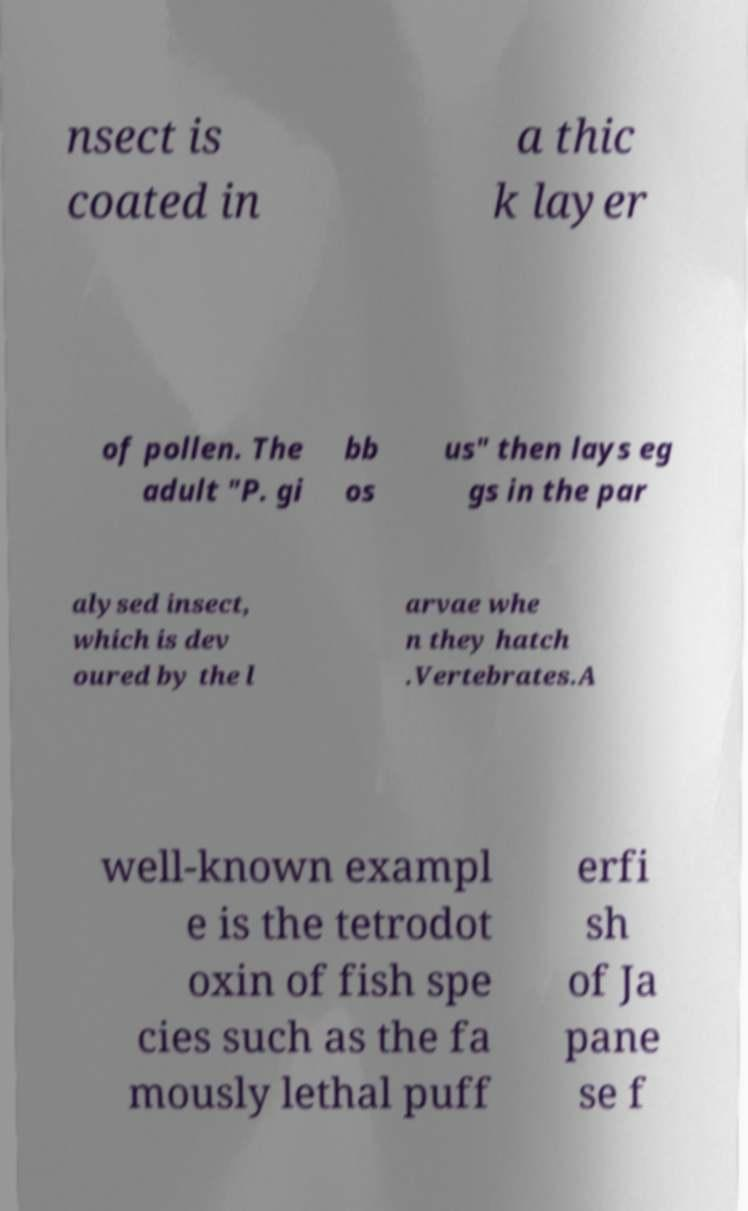Could you assist in decoding the text presented in this image and type it out clearly? nsect is coated in a thic k layer of pollen. The adult "P. gi bb os us" then lays eg gs in the par alysed insect, which is dev oured by the l arvae whe n they hatch .Vertebrates.A well-known exampl e is the tetrodot oxin of fish spe cies such as the fa mously lethal puff erfi sh of Ja pane se f 